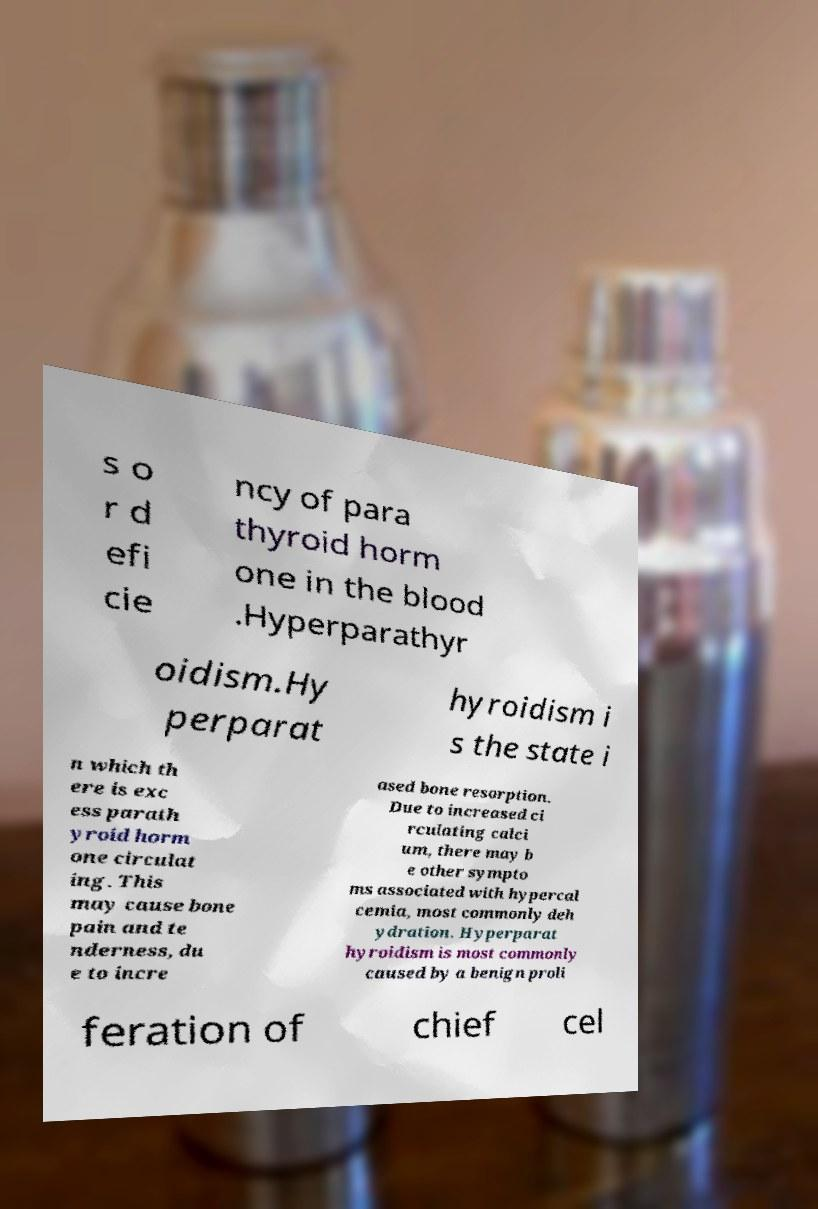Please read and relay the text visible in this image. What does it say? s o r d efi cie ncy of para thyroid horm one in the blood .Hyperparathyr oidism.Hy perparat hyroidism i s the state i n which th ere is exc ess parath yroid horm one circulat ing. This may cause bone pain and te nderness, du e to incre ased bone resorption. Due to increased ci rculating calci um, there may b e other sympto ms associated with hypercal cemia, most commonly deh ydration. Hyperparat hyroidism is most commonly caused by a benign proli feration of chief cel 